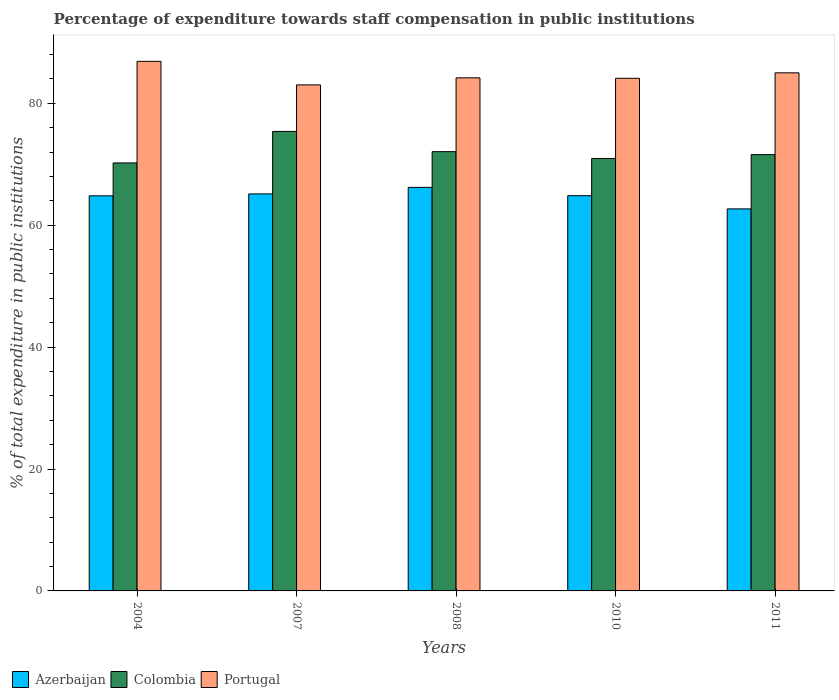How many different coloured bars are there?
Your answer should be compact. 3. How many groups of bars are there?
Your answer should be very brief. 5. Are the number of bars per tick equal to the number of legend labels?
Ensure brevity in your answer.  Yes. Are the number of bars on each tick of the X-axis equal?
Keep it short and to the point. Yes. How many bars are there on the 2nd tick from the left?
Ensure brevity in your answer.  3. What is the label of the 3rd group of bars from the left?
Your answer should be very brief. 2008. What is the percentage of expenditure towards staff compensation in Colombia in 2010?
Provide a short and direct response. 70.95. Across all years, what is the maximum percentage of expenditure towards staff compensation in Colombia?
Make the answer very short. 75.39. Across all years, what is the minimum percentage of expenditure towards staff compensation in Portugal?
Your answer should be compact. 83.03. In which year was the percentage of expenditure towards staff compensation in Portugal minimum?
Your response must be concise. 2007. What is the total percentage of expenditure towards staff compensation in Colombia in the graph?
Your answer should be compact. 360.22. What is the difference between the percentage of expenditure towards staff compensation in Colombia in 2004 and that in 2008?
Ensure brevity in your answer.  -1.85. What is the difference between the percentage of expenditure towards staff compensation in Portugal in 2011 and the percentage of expenditure towards staff compensation in Colombia in 2008?
Offer a very short reply. 12.93. What is the average percentage of expenditure towards staff compensation in Azerbaijan per year?
Your answer should be very brief. 64.74. In the year 2010, what is the difference between the percentage of expenditure towards staff compensation in Portugal and percentage of expenditure towards staff compensation in Colombia?
Keep it short and to the point. 13.16. In how many years, is the percentage of expenditure towards staff compensation in Azerbaijan greater than 20 %?
Your answer should be compact. 5. What is the ratio of the percentage of expenditure towards staff compensation in Azerbaijan in 2007 to that in 2011?
Ensure brevity in your answer.  1.04. Is the percentage of expenditure towards staff compensation in Azerbaijan in 2007 less than that in 2010?
Ensure brevity in your answer.  No. Is the difference between the percentage of expenditure towards staff compensation in Portugal in 2007 and 2011 greater than the difference between the percentage of expenditure towards staff compensation in Colombia in 2007 and 2011?
Your response must be concise. No. What is the difference between the highest and the second highest percentage of expenditure towards staff compensation in Azerbaijan?
Give a very brief answer. 1.07. What is the difference between the highest and the lowest percentage of expenditure towards staff compensation in Azerbaijan?
Provide a short and direct response. 3.53. In how many years, is the percentage of expenditure towards staff compensation in Azerbaijan greater than the average percentage of expenditure towards staff compensation in Azerbaijan taken over all years?
Ensure brevity in your answer.  4. Is the sum of the percentage of expenditure towards staff compensation in Colombia in 2010 and 2011 greater than the maximum percentage of expenditure towards staff compensation in Portugal across all years?
Offer a very short reply. Yes. What does the 1st bar from the right in 2010 represents?
Ensure brevity in your answer.  Portugal. How many bars are there?
Keep it short and to the point. 15. How many years are there in the graph?
Ensure brevity in your answer.  5. Are the values on the major ticks of Y-axis written in scientific E-notation?
Provide a succinct answer. No. Does the graph contain any zero values?
Offer a terse response. No. Where does the legend appear in the graph?
Make the answer very short. Bottom left. How are the legend labels stacked?
Keep it short and to the point. Horizontal. What is the title of the graph?
Ensure brevity in your answer.  Percentage of expenditure towards staff compensation in public institutions. What is the label or title of the X-axis?
Give a very brief answer. Years. What is the label or title of the Y-axis?
Ensure brevity in your answer.  % of total expenditure in public institutions. What is the % of total expenditure in public institutions in Azerbaijan in 2004?
Your response must be concise. 64.83. What is the % of total expenditure in public institutions of Colombia in 2004?
Provide a short and direct response. 70.22. What is the % of total expenditure in public institutions in Portugal in 2004?
Offer a very short reply. 86.89. What is the % of total expenditure in public institutions of Azerbaijan in 2007?
Offer a terse response. 65.14. What is the % of total expenditure in public institutions in Colombia in 2007?
Keep it short and to the point. 75.39. What is the % of total expenditure in public institutions of Portugal in 2007?
Offer a terse response. 83.03. What is the % of total expenditure in public institutions of Azerbaijan in 2008?
Keep it short and to the point. 66.21. What is the % of total expenditure in public institutions in Colombia in 2008?
Your answer should be very brief. 72.07. What is the % of total expenditure in public institutions in Portugal in 2008?
Keep it short and to the point. 84.18. What is the % of total expenditure in public institutions of Azerbaijan in 2010?
Offer a terse response. 64.85. What is the % of total expenditure in public institutions of Colombia in 2010?
Offer a terse response. 70.95. What is the % of total expenditure in public institutions of Portugal in 2010?
Keep it short and to the point. 84.11. What is the % of total expenditure in public institutions of Azerbaijan in 2011?
Ensure brevity in your answer.  62.68. What is the % of total expenditure in public institutions of Colombia in 2011?
Provide a succinct answer. 71.58. What is the % of total expenditure in public institutions of Portugal in 2011?
Make the answer very short. 85. Across all years, what is the maximum % of total expenditure in public institutions in Azerbaijan?
Give a very brief answer. 66.21. Across all years, what is the maximum % of total expenditure in public institutions of Colombia?
Give a very brief answer. 75.39. Across all years, what is the maximum % of total expenditure in public institutions of Portugal?
Your response must be concise. 86.89. Across all years, what is the minimum % of total expenditure in public institutions of Azerbaijan?
Your response must be concise. 62.68. Across all years, what is the minimum % of total expenditure in public institutions of Colombia?
Your answer should be very brief. 70.22. Across all years, what is the minimum % of total expenditure in public institutions of Portugal?
Provide a succinct answer. 83.03. What is the total % of total expenditure in public institutions in Azerbaijan in the graph?
Your answer should be very brief. 323.7. What is the total % of total expenditure in public institutions of Colombia in the graph?
Offer a terse response. 360.22. What is the total % of total expenditure in public institutions of Portugal in the graph?
Ensure brevity in your answer.  423.22. What is the difference between the % of total expenditure in public institutions in Azerbaijan in 2004 and that in 2007?
Offer a terse response. -0.31. What is the difference between the % of total expenditure in public institutions in Colombia in 2004 and that in 2007?
Ensure brevity in your answer.  -5.17. What is the difference between the % of total expenditure in public institutions of Portugal in 2004 and that in 2007?
Give a very brief answer. 3.86. What is the difference between the % of total expenditure in public institutions of Azerbaijan in 2004 and that in 2008?
Keep it short and to the point. -1.39. What is the difference between the % of total expenditure in public institutions of Colombia in 2004 and that in 2008?
Ensure brevity in your answer.  -1.85. What is the difference between the % of total expenditure in public institutions in Portugal in 2004 and that in 2008?
Offer a terse response. 2.7. What is the difference between the % of total expenditure in public institutions of Azerbaijan in 2004 and that in 2010?
Give a very brief answer. -0.02. What is the difference between the % of total expenditure in public institutions of Colombia in 2004 and that in 2010?
Your response must be concise. -0.73. What is the difference between the % of total expenditure in public institutions of Portugal in 2004 and that in 2010?
Offer a very short reply. 2.78. What is the difference between the % of total expenditure in public institutions of Azerbaijan in 2004 and that in 2011?
Provide a short and direct response. 2.15. What is the difference between the % of total expenditure in public institutions in Colombia in 2004 and that in 2011?
Your answer should be compact. -1.36. What is the difference between the % of total expenditure in public institutions in Portugal in 2004 and that in 2011?
Your answer should be compact. 1.88. What is the difference between the % of total expenditure in public institutions in Azerbaijan in 2007 and that in 2008?
Keep it short and to the point. -1.07. What is the difference between the % of total expenditure in public institutions of Colombia in 2007 and that in 2008?
Offer a very short reply. 3.32. What is the difference between the % of total expenditure in public institutions in Portugal in 2007 and that in 2008?
Ensure brevity in your answer.  -1.15. What is the difference between the % of total expenditure in public institutions of Azerbaijan in 2007 and that in 2010?
Offer a terse response. 0.29. What is the difference between the % of total expenditure in public institutions in Colombia in 2007 and that in 2010?
Give a very brief answer. 4.44. What is the difference between the % of total expenditure in public institutions of Portugal in 2007 and that in 2010?
Give a very brief answer. -1.08. What is the difference between the % of total expenditure in public institutions in Azerbaijan in 2007 and that in 2011?
Offer a terse response. 2.46. What is the difference between the % of total expenditure in public institutions in Colombia in 2007 and that in 2011?
Provide a short and direct response. 3.81. What is the difference between the % of total expenditure in public institutions in Portugal in 2007 and that in 2011?
Offer a very short reply. -1.97. What is the difference between the % of total expenditure in public institutions in Azerbaijan in 2008 and that in 2010?
Provide a succinct answer. 1.36. What is the difference between the % of total expenditure in public institutions of Colombia in 2008 and that in 2010?
Make the answer very short. 1.12. What is the difference between the % of total expenditure in public institutions of Portugal in 2008 and that in 2010?
Offer a terse response. 0.07. What is the difference between the % of total expenditure in public institutions in Azerbaijan in 2008 and that in 2011?
Your answer should be compact. 3.53. What is the difference between the % of total expenditure in public institutions in Colombia in 2008 and that in 2011?
Ensure brevity in your answer.  0.49. What is the difference between the % of total expenditure in public institutions of Portugal in 2008 and that in 2011?
Make the answer very short. -0.82. What is the difference between the % of total expenditure in public institutions of Azerbaijan in 2010 and that in 2011?
Your response must be concise. 2.17. What is the difference between the % of total expenditure in public institutions in Colombia in 2010 and that in 2011?
Your answer should be compact. -0.63. What is the difference between the % of total expenditure in public institutions of Portugal in 2010 and that in 2011?
Make the answer very short. -0.89. What is the difference between the % of total expenditure in public institutions in Azerbaijan in 2004 and the % of total expenditure in public institutions in Colombia in 2007?
Offer a very short reply. -10.57. What is the difference between the % of total expenditure in public institutions in Azerbaijan in 2004 and the % of total expenditure in public institutions in Portugal in 2007?
Make the answer very short. -18.2. What is the difference between the % of total expenditure in public institutions in Colombia in 2004 and the % of total expenditure in public institutions in Portugal in 2007?
Offer a very short reply. -12.81. What is the difference between the % of total expenditure in public institutions of Azerbaijan in 2004 and the % of total expenditure in public institutions of Colombia in 2008?
Make the answer very short. -7.25. What is the difference between the % of total expenditure in public institutions in Azerbaijan in 2004 and the % of total expenditure in public institutions in Portugal in 2008?
Provide a short and direct response. -19.36. What is the difference between the % of total expenditure in public institutions in Colombia in 2004 and the % of total expenditure in public institutions in Portugal in 2008?
Your answer should be compact. -13.96. What is the difference between the % of total expenditure in public institutions of Azerbaijan in 2004 and the % of total expenditure in public institutions of Colombia in 2010?
Your answer should be compact. -6.13. What is the difference between the % of total expenditure in public institutions in Azerbaijan in 2004 and the % of total expenditure in public institutions in Portugal in 2010?
Give a very brief answer. -19.28. What is the difference between the % of total expenditure in public institutions in Colombia in 2004 and the % of total expenditure in public institutions in Portugal in 2010?
Offer a terse response. -13.89. What is the difference between the % of total expenditure in public institutions of Azerbaijan in 2004 and the % of total expenditure in public institutions of Colombia in 2011?
Offer a very short reply. -6.76. What is the difference between the % of total expenditure in public institutions of Azerbaijan in 2004 and the % of total expenditure in public institutions of Portugal in 2011?
Your response must be concise. -20.18. What is the difference between the % of total expenditure in public institutions of Colombia in 2004 and the % of total expenditure in public institutions of Portugal in 2011?
Give a very brief answer. -14.78. What is the difference between the % of total expenditure in public institutions in Azerbaijan in 2007 and the % of total expenditure in public institutions in Colombia in 2008?
Offer a very short reply. -6.93. What is the difference between the % of total expenditure in public institutions in Azerbaijan in 2007 and the % of total expenditure in public institutions in Portugal in 2008?
Make the answer very short. -19.05. What is the difference between the % of total expenditure in public institutions of Colombia in 2007 and the % of total expenditure in public institutions of Portugal in 2008?
Keep it short and to the point. -8.79. What is the difference between the % of total expenditure in public institutions of Azerbaijan in 2007 and the % of total expenditure in public institutions of Colombia in 2010?
Offer a terse response. -5.81. What is the difference between the % of total expenditure in public institutions of Azerbaijan in 2007 and the % of total expenditure in public institutions of Portugal in 2010?
Ensure brevity in your answer.  -18.97. What is the difference between the % of total expenditure in public institutions in Colombia in 2007 and the % of total expenditure in public institutions in Portugal in 2010?
Your answer should be very brief. -8.72. What is the difference between the % of total expenditure in public institutions of Azerbaijan in 2007 and the % of total expenditure in public institutions of Colombia in 2011?
Your answer should be very brief. -6.44. What is the difference between the % of total expenditure in public institutions of Azerbaijan in 2007 and the % of total expenditure in public institutions of Portugal in 2011?
Provide a short and direct response. -19.86. What is the difference between the % of total expenditure in public institutions of Colombia in 2007 and the % of total expenditure in public institutions of Portugal in 2011?
Provide a short and direct response. -9.61. What is the difference between the % of total expenditure in public institutions in Azerbaijan in 2008 and the % of total expenditure in public institutions in Colombia in 2010?
Your response must be concise. -4.74. What is the difference between the % of total expenditure in public institutions in Azerbaijan in 2008 and the % of total expenditure in public institutions in Portugal in 2010?
Offer a very short reply. -17.9. What is the difference between the % of total expenditure in public institutions in Colombia in 2008 and the % of total expenditure in public institutions in Portugal in 2010?
Offer a terse response. -12.04. What is the difference between the % of total expenditure in public institutions of Azerbaijan in 2008 and the % of total expenditure in public institutions of Colombia in 2011?
Give a very brief answer. -5.37. What is the difference between the % of total expenditure in public institutions in Azerbaijan in 2008 and the % of total expenditure in public institutions in Portugal in 2011?
Your answer should be very brief. -18.79. What is the difference between the % of total expenditure in public institutions in Colombia in 2008 and the % of total expenditure in public institutions in Portugal in 2011?
Your response must be concise. -12.93. What is the difference between the % of total expenditure in public institutions of Azerbaijan in 2010 and the % of total expenditure in public institutions of Colombia in 2011?
Provide a short and direct response. -6.74. What is the difference between the % of total expenditure in public institutions in Azerbaijan in 2010 and the % of total expenditure in public institutions in Portugal in 2011?
Offer a terse response. -20.16. What is the difference between the % of total expenditure in public institutions of Colombia in 2010 and the % of total expenditure in public institutions of Portugal in 2011?
Give a very brief answer. -14.05. What is the average % of total expenditure in public institutions in Azerbaijan per year?
Keep it short and to the point. 64.74. What is the average % of total expenditure in public institutions of Colombia per year?
Provide a short and direct response. 72.04. What is the average % of total expenditure in public institutions of Portugal per year?
Your response must be concise. 84.64. In the year 2004, what is the difference between the % of total expenditure in public institutions in Azerbaijan and % of total expenditure in public institutions in Colombia?
Your answer should be very brief. -5.4. In the year 2004, what is the difference between the % of total expenditure in public institutions in Azerbaijan and % of total expenditure in public institutions in Portugal?
Offer a very short reply. -22.06. In the year 2004, what is the difference between the % of total expenditure in public institutions of Colombia and % of total expenditure in public institutions of Portugal?
Your answer should be compact. -16.66. In the year 2007, what is the difference between the % of total expenditure in public institutions in Azerbaijan and % of total expenditure in public institutions in Colombia?
Provide a short and direct response. -10.25. In the year 2007, what is the difference between the % of total expenditure in public institutions of Azerbaijan and % of total expenditure in public institutions of Portugal?
Offer a terse response. -17.89. In the year 2007, what is the difference between the % of total expenditure in public institutions of Colombia and % of total expenditure in public institutions of Portugal?
Offer a terse response. -7.64. In the year 2008, what is the difference between the % of total expenditure in public institutions in Azerbaijan and % of total expenditure in public institutions in Colombia?
Your answer should be very brief. -5.86. In the year 2008, what is the difference between the % of total expenditure in public institutions of Azerbaijan and % of total expenditure in public institutions of Portugal?
Your response must be concise. -17.97. In the year 2008, what is the difference between the % of total expenditure in public institutions in Colombia and % of total expenditure in public institutions in Portugal?
Provide a short and direct response. -12.11. In the year 2010, what is the difference between the % of total expenditure in public institutions of Azerbaijan and % of total expenditure in public institutions of Colombia?
Ensure brevity in your answer.  -6.11. In the year 2010, what is the difference between the % of total expenditure in public institutions of Azerbaijan and % of total expenditure in public institutions of Portugal?
Keep it short and to the point. -19.26. In the year 2010, what is the difference between the % of total expenditure in public institutions of Colombia and % of total expenditure in public institutions of Portugal?
Keep it short and to the point. -13.16. In the year 2011, what is the difference between the % of total expenditure in public institutions in Azerbaijan and % of total expenditure in public institutions in Colombia?
Provide a short and direct response. -8.9. In the year 2011, what is the difference between the % of total expenditure in public institutions in Azerbaijan and % of total expenditure in public institutions in Portugal?
Your response must be concise. -22.32. In the year 2011, what is the difference between the % of total expenditure in public institutions of Colombia and % of total expenditure in public institutions of Portugal?
Give a very brief answer. -13.42. What is the ratio of the % of total expenditure in public institutions in Azerbaijan in 2004 to that in 2007?
Provide a short and direct response. 1. What is the ratio of the % of total expenditure in public institutions in Colombia in 2004 to that in 2007?
Offer a very short reply. 0.93. What is the ratio of the % of total expenditure in public institutions in Portugal in 2004 to that in 2007?
Your response must be concise. 1.05. What is the ratio of the % of total expenditure in public institutions of Azerbaijan in 2004 to that in 2008?
Offer a very short reply. 0.98. What is the ratio of the % of total expenditure in public institutions in Colombia in 2004 to that in 2008?
Offer a terse response. 0.97. What is the ratio of the % of total expenditure in public institutions of Portugal in 2004 to that in 2008?
Offer a very short reply. 1.03. What is the ratio of the % of total expenditure in public institutions in Azerbaijan in 2004 to that in 2010?
Provide a succinct answer. 1. What is the ratio of the % of total expenditure in public institutions of Colombia in 2004 to that in 2010?
Make the answer very short. 0.99. What is the ratio of the % of total expenditure in public institutions in Portugal in 2004 to that in 2010?
Provide a short and direct response. 1.03. What is the ratio of the % of total expenditure in public institutions in Azerbaijan in 2004 to that in 2011?
Provide a short and direct response. 1.03. What is the ratio of the % of total expenditure in public institutions of Portugal in 2004 to that in 2011?
Provide a succinct answer. 1.02. What is the ratio of the % of total expenditure in public institutions in Azerbaijan in 2007 to that in 2008?
Your answer should be very brief. 0.98. What is the ratio of the % of total expenditure in public institutions in Colombia in 2007 to that in 2008?
Provide a short and direct response. 1.05. What is the ratio of the % of total expenditure in public institutions in Portugal in 2007 to that in 2008?
Your response must be concise. 0.99. What is the ratio of the % of total expenditure in public institutions of Colombia in 2007 to that in 2010?
Provide a short and direct response. 1.06. What is the ratio of the % of total expenditure in public institutions in Portugal in 2007 to that in 2010?
Ensure brevity in your answer.  0.99. What is the ratio of the % of total expenditure in public institutions in Azerbaijan in 2007 to that in 2011?
Provide a short and direct response. 1.04. What is the ratio of the % of total expenditure in public institutions in Colombia in 2007 to that in 2011?
Provide a short and direct response. 1.05. What is the ratio of the % of total expenditure in public institutions of Portugal in 2007 to that in 2011?
Make the answer very short. 0.98. What is the ratio of the % of total expenditure in public institutions of Colombia in 2008 to that in 2010?
Make the answer very short. 1.02. What is the ratio of the % of total expenditure in public institutions of Azerbaijan in 2008 to that in 2011?
Your response must be concise. 1.06. What is the ratio of the % of total expenditure in public institutions in Colombia in 2008 to that in 2011?
Make the answer very short. 1.01. What is the ratio of the % of total expenditure in public institutions of Portugal in 2008 to that in 2011?
Provide a short and direct response. 0.99. What is the ratio of the % of total expenditure in public institutions in Azerbaijan in 2010 to that in 2011?
Keep it short and to the point. 1.03. What is the difference between the highest and the second highest % of total expenditure in public institutions of Azerbaijan?
Offer a terse response. 1.07. What is the difference between the highest and the second highest % of total expenditure in public institutions of Colombia?
Your response must be concise. 3.32. What is the difference between the highest and the second highest % of total expenditure in public institutions of Portugal?
Your answer should be very brief. 1.88. What is the difference between the highest and the lowest % of total expenditure in public institutions of Azerbaijan?
Provide a short and direct response. 3.53. What is the difference between the highest and the lowest % of total expenditure in public institutions of Colombia?
Give a very brief answer. 5.17. What is the difference between the highest and the lowest % of total expenditure in public institutions of Portugal?
Make the answer very short. 3.86. 